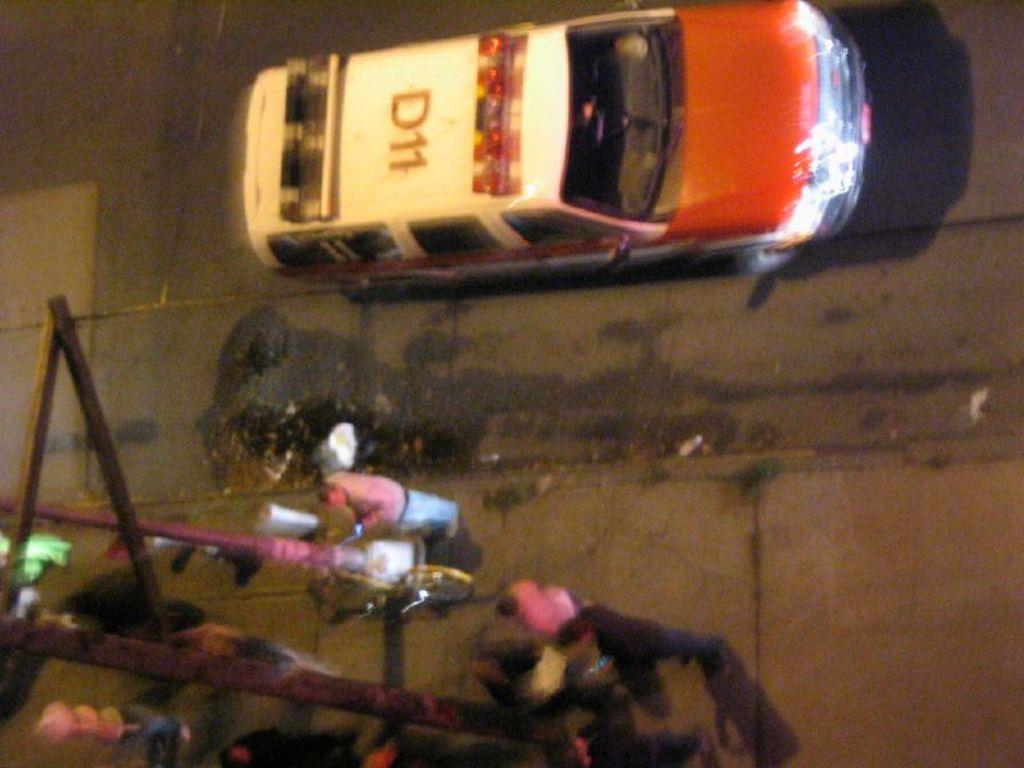What is the main subject of the image? The main subject of the image is vehicles on the road. Where are the vehicles located in the image? The vehicles are in the center of the image. What else can be seen in the image besides the vehicles? There are poles visible in the image. Are there any people present in the image? Yes, there are people standing in the image. What unit of measurement is being used to determine the side of the vehicles in the image? There is no specific unit of measurement mentioned in the image, and the side of the vehicles is not being measured. 